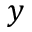<formula> <loc_0><loc_0><loc_500><loc_500>y</formula> 